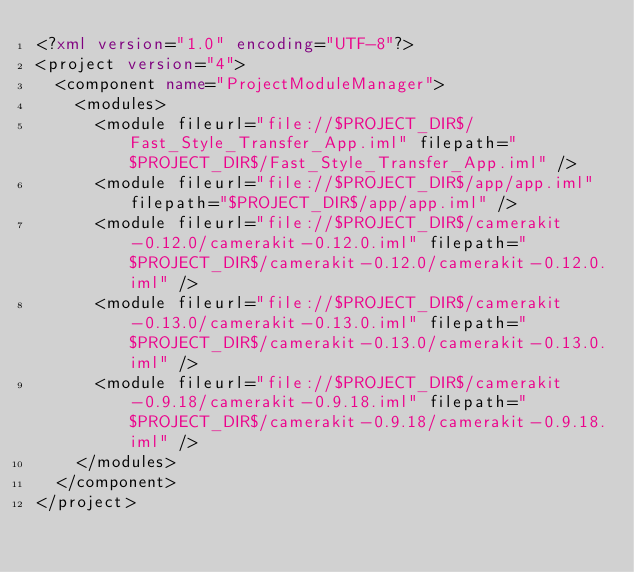<code> <loc_0><loc_0><loc_500><loc_500><_XML_><?xml version="1.0" encoding="UTF-8"?>
<project version="4">
  <component name="ProjectModuleManager">
    <modules>
      <module fileurl="file://$PROJECT_DIR$/Fast_Style_Transfer_App.iml" filepath="$PROJECT_DIR$/Fast_Style_Transfer_App.iml" />
      <module fileurl="file://$PROJECT_DIR$/app/app.iml" filepath="$PROJECT_DIR$/app/app.iml" />
      <module fileurl="file://$PROJECT_DIR$/camerakit-0.12.0/camerakit-0.12.0.iml" filepath="$PROJECT_DIR$/camerakit-0.12.0/camerakit-0.12.0.iml" />
      <module fileurl="file://$PROJECT_DIR$/camerakit-0.13.0/camerakit-0.13.0.iml" filepath="$PROJECT_DIR$/camerakit-0.13.0/camerakit-0.13.0.iml" />
      <module fileurl="file://$PROJECT_DIR$/camerakit-0.9.18/camerakit-0.9.18.iml" filepath="$PROJECT_DIR$/camerakit-0.9.18/camerakit-0.9.18.iml" />
    </modules>
  </component>
</project></code> 